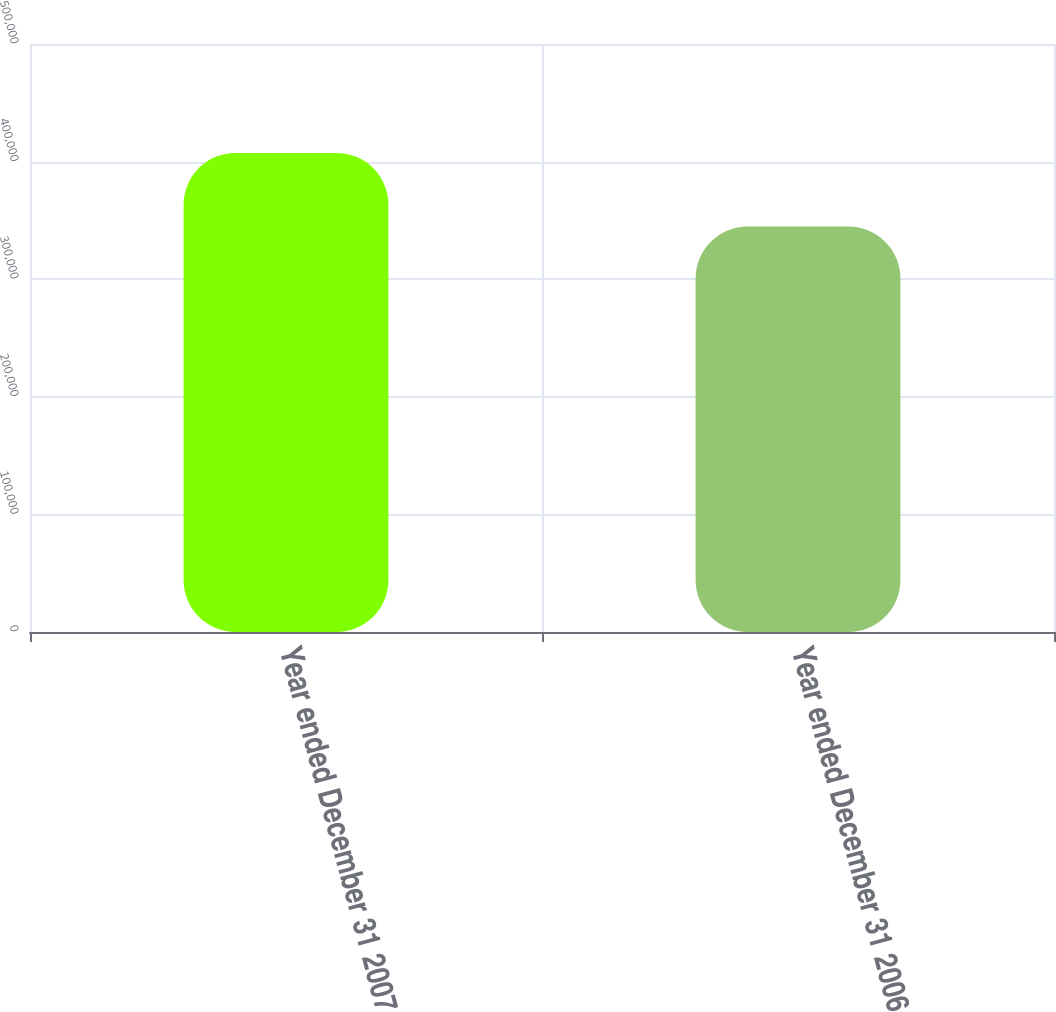<chart> <loc_0><loc_0><loc_500><loc_500><bar_chart><fcel>Year ended December 31 2007<fcel>Year ended December 31 2006<nl><fcel>407416<fcel>344822<nl></chart> 